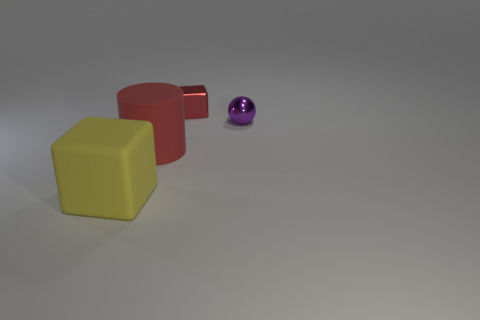Add 1 tiny gray matte things. How many objects exist? 5 Subtract all spheres. How many objects are left? 3 Add 4 big yellow blocks. How many big yellow blocks are left? 5 Add 1 tiny red objects. How many tiny red objects exist? 2 Subtract 0 cyan cylinders. How many objects are left? 4 Subtract all small green blocks. Subtract all yellow rubber objects. How many objects are left? 3 